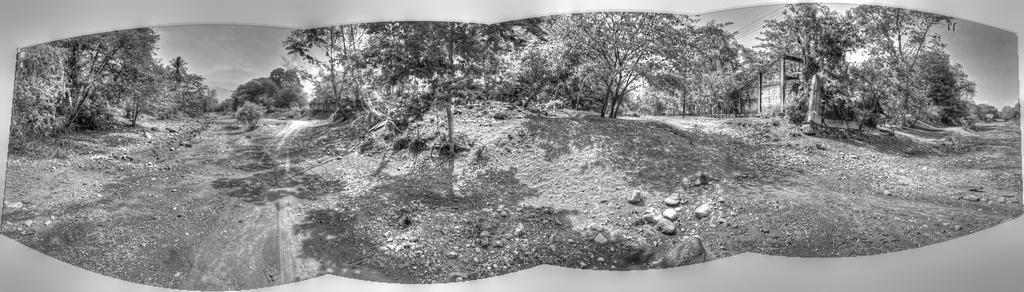What is the color scheme of the image? The image is black and white. What can be seen on the ground in the image? There are rocks on the ground in the image. What type of structure is present in the image? There is a house in the image. What is visible in the background of the image? The sky is visible in the background of the image. Where is the picture of the chicken located in the image? There is no picture of a chicken present in the image. What type of box can be seen near the house in the image? There is no box visible near the house in the image. 